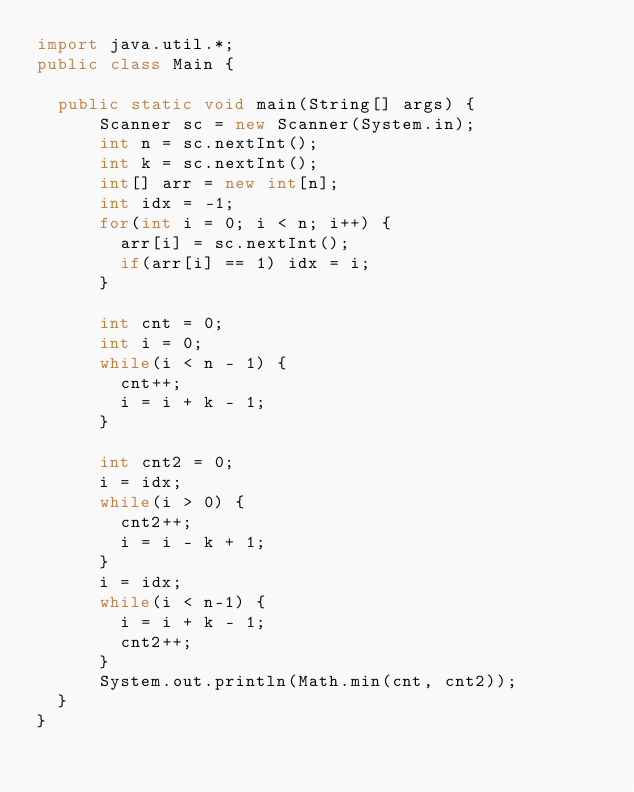Convert code to text. <code><loc_0><loc_0><loc_500><loc_500><_Java_>import java.util.*;
public class Main {

  public static void main(String[] args) { 
      Scanner sc = new Scanner(System.in);
      int n = sc.nextInt();
      int k = sc.nextInt();
      int[] arr = new int[n];
      int idx = -1;
      for(int i = 0; i < n; i++) {
        arr[i] = sc.nextInt();
        if(arr[i] == 1) idx = i;
      }

      int cnt = 0;
      int i = 0;
      while(i < n - 1) {
        cnt++;
        i = i + k - 1;
      }
     
      int cnt2 = 0;
      i = idx;
      while(i > 0) {
        cnt2++;
        i = i - k + 1;
      }
      i = idx;
      while(i < n-1) {
        i = i + k - 1;
        cnt2++;
      }
      System.out.println(Math.min(cnt, cnt2));
  }
}</code> 